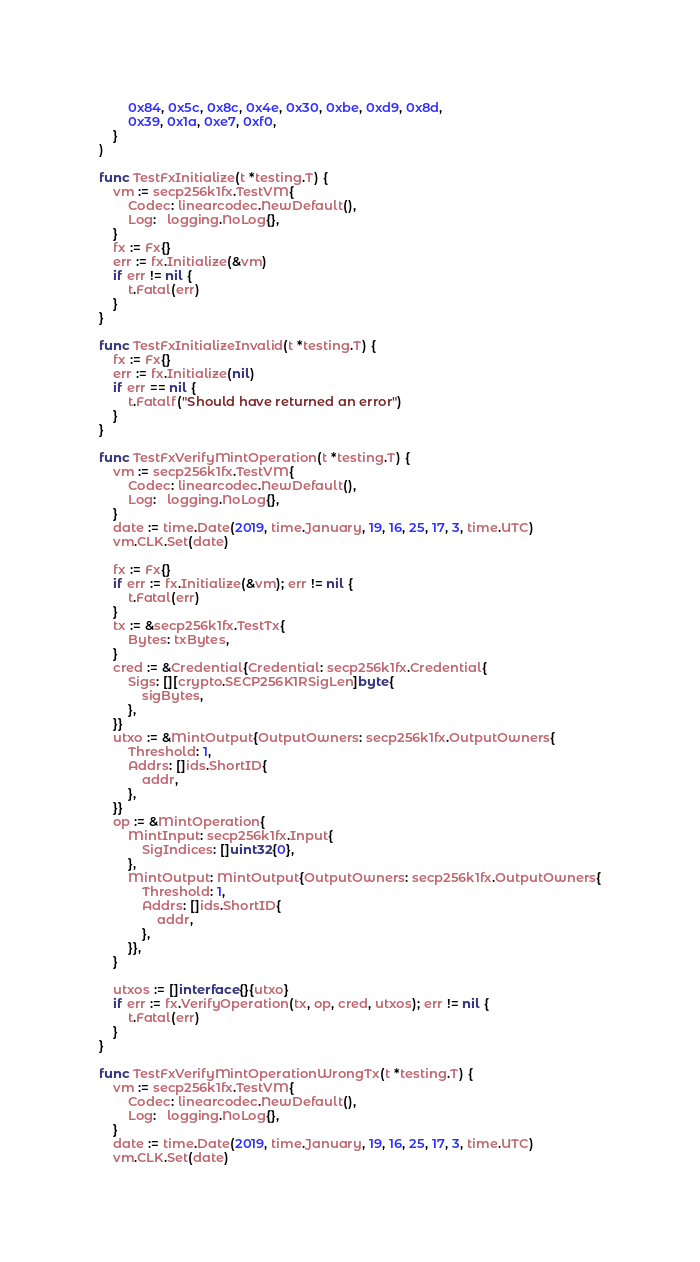Convert code to text. <code><loc_0><loc_0><loc_500><loc_500><_Go_>		0x84, 0x5c, 0x8c, 0x4e, 0x30, 0xbe, 0xd9, 0x8d,
		0x39, 0x1a, 0xe7, 0xf0,
	}
)

func TestFxInitialize(t *testing.T) {
	vm := secp256k1fx.TestVM{
		Codec: linearcodec.NewDefault(),
		Log:   logging.NoLog{},
	}
	fx := Fx{}
	err := fx.Initialize(&vm)
	if err != nil {
		t.Fatal(err)
	}
}

func TestFxInitializeInvalid(t *testing.T) {
	fx := Fx{}
	err := fx.Initialize(nil)
	if err == nil {
		t.Fatalf("Should have returned an error")
	}
}

func TestFxVerifyMintOperation(t *testing.T) {
	vm := secp256k1fx.TestVM{
		Codec: linearcodec.NewDefault(),
		Log:   logging.NoLog{},
	}
	date := time.Date(2019, time.January, 19, 16, 25, 17, 3, time.UTC)
	vm.CLK.Set(date)

	fx := Fx{}
	if err := fx.Initialize(&vm); err != nil {
		t.Fatal(err)
	}
	tx := &secp256k1fx.TestTx{
		Bytes: txBytes,
	}
	cred := &Credential{Credential: secp256k1fx.Credential{
		Sigs: [][crypto.SECP256K1RSigLen]byte{
			sigBytes,
		},
	}}
	utxo := &MintOutput{OutputOwners: secp256k1fx.OutputOwners{
		Threshold: 1,
		Addrs: []ids.ShortID{
			addr,
		},
	}}
	op := &MintOperation{
		MintInput: secp256k1fx.Input{
			SigIndices: []uint32{0},
		},
		MintOutput: MintOutput{OutputOwners: secp256k1fx.OutputOwners{
			Threshold: 1,
			Addrs: []ids.ShortID{
				addr,
			},
		}},
	}

	utxos := []interface{}{utxo}
	if err := fx.VerifyOperation(tx, op, cred, utxos); err != nil {
		t.Fatal(err)
	}
}

func TestFxVerifyMintOperationWrongTx(t *testing.T) {
	vm := secp256k1fx.TestVM{
		Codec: linearcodec.NewDefault(),
		Log:   logging.NoLog{},
	}
	date := time.Date(2019, time.January, 19, 16, 25, 17, 3, time.UTC)
	vm.CLK.Set(date)
</code> 